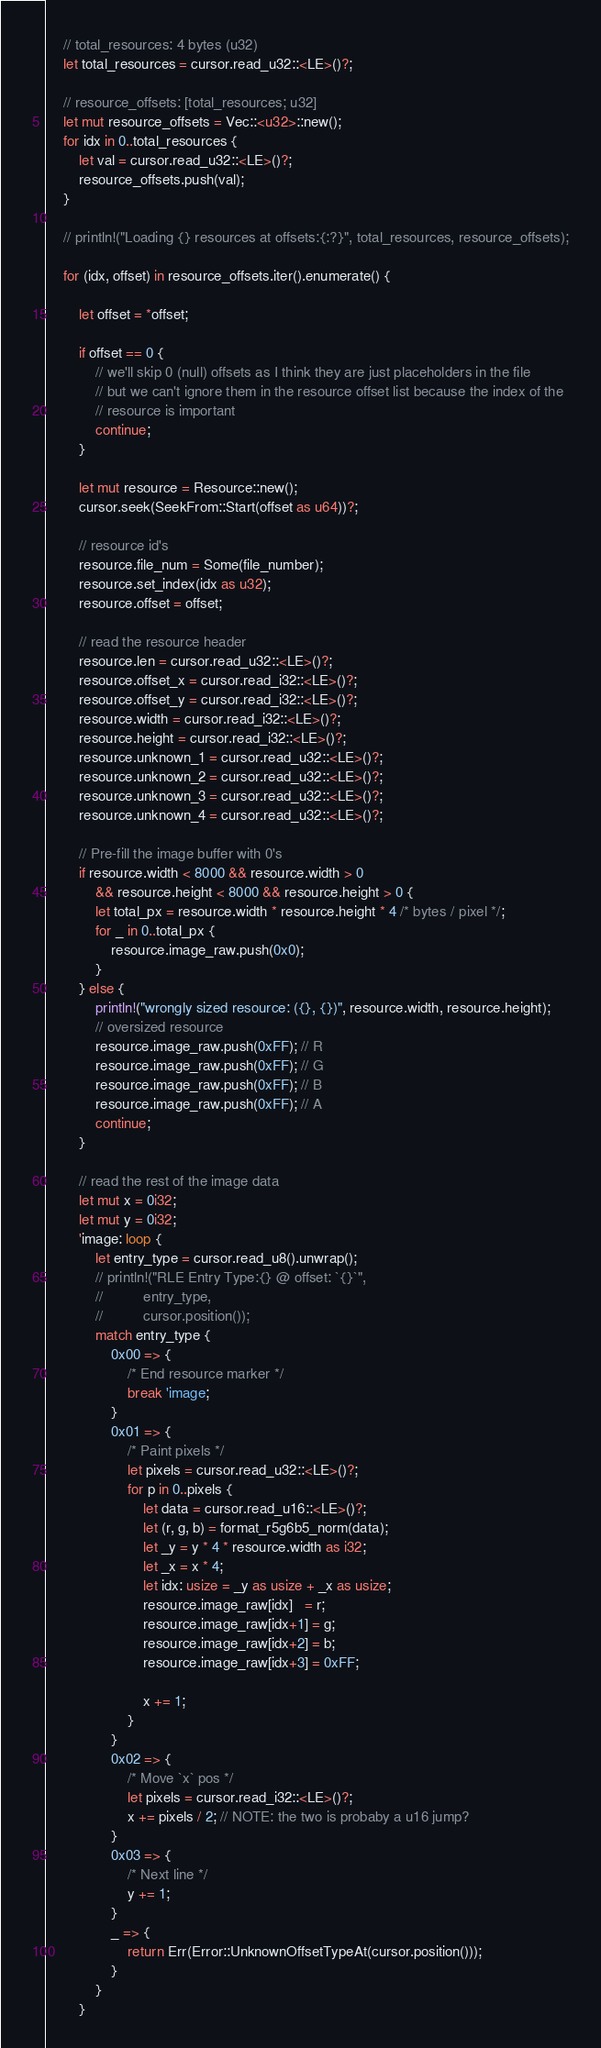Convert code to text. <code><loc_0><loc_0><loc_500><loc_500><_Rust_>    // total_resources: 4 bytes (u32)
    let total_resources = cursor.read_u32::<LE>()?;

    // resource_offsets: [total_resources; u32]
    let mut resource_offsets = Vec::<u32>::new();
    for idx in 0..total_resources {
        let val = cursor.read_u32::<LE>()?;
        resource_offsets.push(val);
    }

    // println!("Loading {} resources at offsets:{:?}", total_resources, resource_offsets);

    for (idx, offset) in resource_offsets.iter().enumerate() {

        let offset = *offset;

        if offset == 0 {
            // we'll skip 0 (null) offsets as I think they are just placeholders in the file
            // but we can't ignore them in the resource offset list because the index of the
            // resource is important
            continue;
        }

        let mut resource = Resource::new();
        cursor.seek(SeekFrom::Start(offset as u64))?;

        // resource id's
        resource.file_num = Some(file_number);
        resource.set_index(idx as u32);
        resource.offset = offset;

        // read the resource header
        resource.len = cursor.read_u32::<LE>()?;
        resource.offset_x = cursor.read_i32::<LE>()?;
        resource.offset_y = cursor.read_i32::<LE>()?;
        resource.width = cursor.read_i32::<LE>()?;
        resource.height = cursor.read_i32::<LE>()?;
        resource.unknown_1 = cursor.read_u32::<LE>()?;
        resource.unknown_2 = cursor.read_u32::<LE>()?;
        resource.unknown_3 = cursor.read_u32::<LE>()?;
        resource.unknown_4 = cursor.read_u32::<LE>()?;

        // Pre-fill the image buffer with 0's
        if resource.width < 8000 && resource.width > 0
            && resource.height < 8000 && resource.height > 0 {
            let total_px = resource.width * resource.height * 4 /* bytes / pixel */;
            for _ in 0..total_px {
                resource.image_raw.push(0x0);
            }
        } else {
            println!("wrongly sized resource: ({}, {})", resource.width, resource.height);
            // oversized resource
            resource.image_raw.push(0xFF); // R
            resource.image_raw.push(0xFF); // G
            resource.image_raw.push(0xFF); // B
            resource.image_raw.push(0xFF); // A
            continue;
        }

        // read the rest of the image data
        let mut x = 0i32;
        let mut y = 0i32;
        'image: loop {
            let entry_type = cursor.read_u8().unwrap();
            // println!("RLE Entry Type:{} @ offset: `{}`",
            //          entry_type,
            //          cursor.position());
            match entry_type {
                0x00 => {
                    /* End resource marker */
                    break 'image;
                }
                0x01 => {
                    /* Paint pixels */
                    let pixels = cursor.read_u32::<LE>()?;
                    for p in 0..pixels {
                        let data = cursor.read_u16::<LE>()?;
                        let (r, g, b) = format_r5g6b5_norm(data);
                        let _y = y * 4 * resource.width as i32;
                        let _x = x * 4;
                        let idx: usize = _y as usize + _x as usize;
                        resource.image_raw[idx]   = r;
                        resource.image_raw[idx+1] = g;
                        resource.image_raw[idx+2] = b;
                        resource.image_raw[idx+3] = 0xFF;

                        x += 1;
                    }
                }
                0x02 => {
                    /* Move `x` pos */
                    let pixels = cursor.read_i32::<LE>()?;
                    x += pixels / 2; // NOTE: the two is probaby a u16 jump?
                }
                0x03 => {
                    /* Next line */
                    y += 1;
                }
                _ => {
                    return Err(Error::UnknownOffsetTypeAt(cursor.position()));
                }
            }
        }</code> 